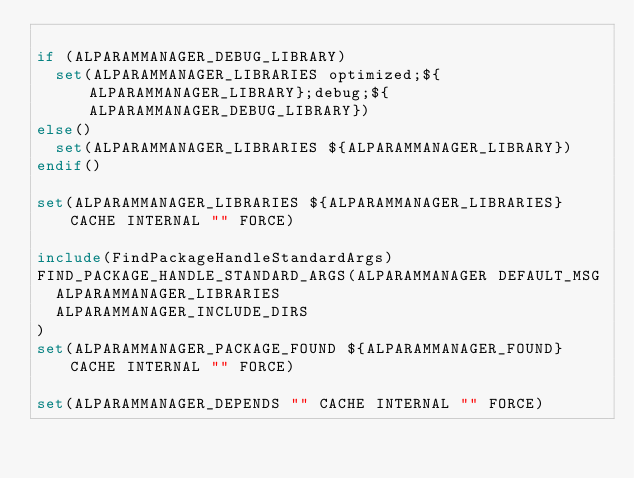<code> <loc_0><loc_0><loc_500><loc_500><_CMake_>
if (ALPARAMMANAGER_DEBUG_LIBRARY)
  set(ALPARAMMANAGER_LIBRARIES optimized;${ALPARAMMANAGER_LIBRARY};debug;${ALPARAMMANAGER_DEBUG_LIBRARY})
else()
  set(ALPARAMMANAGER_LIBRARIES ${ALPARAMMANAGER_LIBRARY})
endif()

set(ALPARAMMANAGER_LIBRARIES ${ALPARAMMANAGER_LIBRARIES} CACHE INTERNAL "" FORCE)
 
include(FindPackageHandleStandardArgs)
FIND_PACKAGE_HANDLE_STANDARD_ARGS(ALPARAMMANAGER DEFAULT_MSG
  ALPARAMMANAGER_LIBRARIES
  ALPARAMMANAGER_INCLUDE_DIRS
)
set(ALPARAMMANAGER_PACKAGE_FOUND ${ALPARAMMANAGER_FOUND} CACHE INTERNAL "" FORCE)
 
set(ALPARAMMANAGER_DEPENDS "" CACHE INTERNAL "" FORCE)
 </code> 